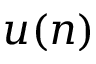Convert formula to latex. <formula><loc_0><loc_0><loc_500><loc_500>u ( n )</formula> 